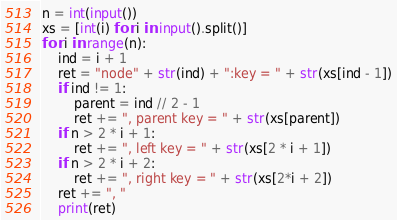<code> <loc_0><loc_0><loc_500><loc_500><_Python_>n = int(input())
xs = [int(i) for i in input().split()]
for i in range(n):
    ind = i + 1
    ret = "node" + str(ind) + ":key = " + str(xs[ind - 1])
    if ind != 1:
        parent = ind // 2 - 1
        ret += ", parent key = " + str(xs[parent])
    if n > 2 * i + 1:
        ret += ", left key = " + str(xs[2 * i + 1])
    if n > 2 * i + 2:
        ret += ", right key = " + str(xs[2*i + 2])
    ret += ", "
    print(ret)</code> 